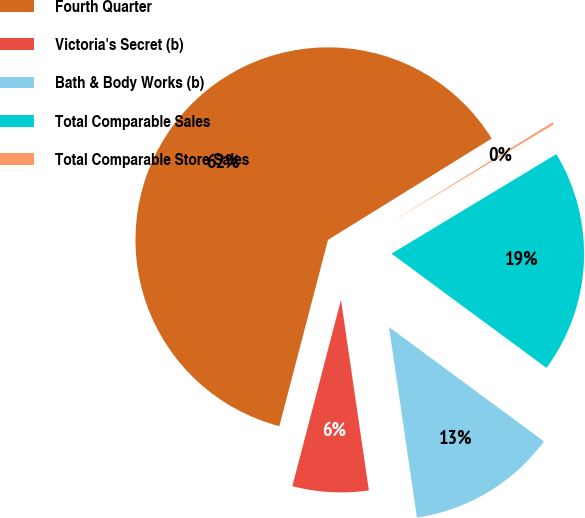Convert chart. <chart><loc_0><loc_0><loc_500><loc_500><pie_chart><fcel>Fourth Quarter<fcel>Victoria's Secret (b)<fcel>Bath & Body Works (b)<fcel>Total Comparable Sales<fcel>Total Comparable Store Sales<nl><fcel>62.11%<fcel>6.38%<fcel>12.57%<fcel>18.76%<fcel>0.18%<nl></chart> 